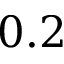Convert formula to latex. <formula><loc_0><loc_0><loc_500><loc_500>0 . 2</formula> 